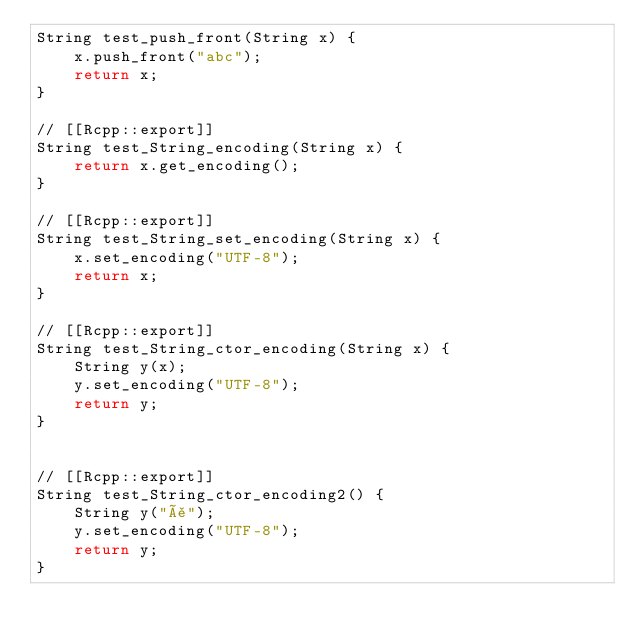<code> <loc_0><loc_0><loc_500><loc_500><_C++_>String test_push_front(String x) {
    x.push_front("abc");
    return x;
}

// [[Rcpp::export]]
String test_String_encoding(String x) {
    return x.get_encoding();
}

// [[Rcpp::export]]
String test_String_set_encoding(String x) {
    x.set_encoding("UTF-8");
    return x;
}

// [[Rcpp::export]]
String test_String_ctor_encoding(String x) {
    String y(x);
    y.set_encoding("UTF-8");
    return y;
}


// [[Rcpp::export]]
String test_String_ctor_encoding2() {
    String y("å");
    y.set_encoding("UTF-8");
    return y;
}
</code> 